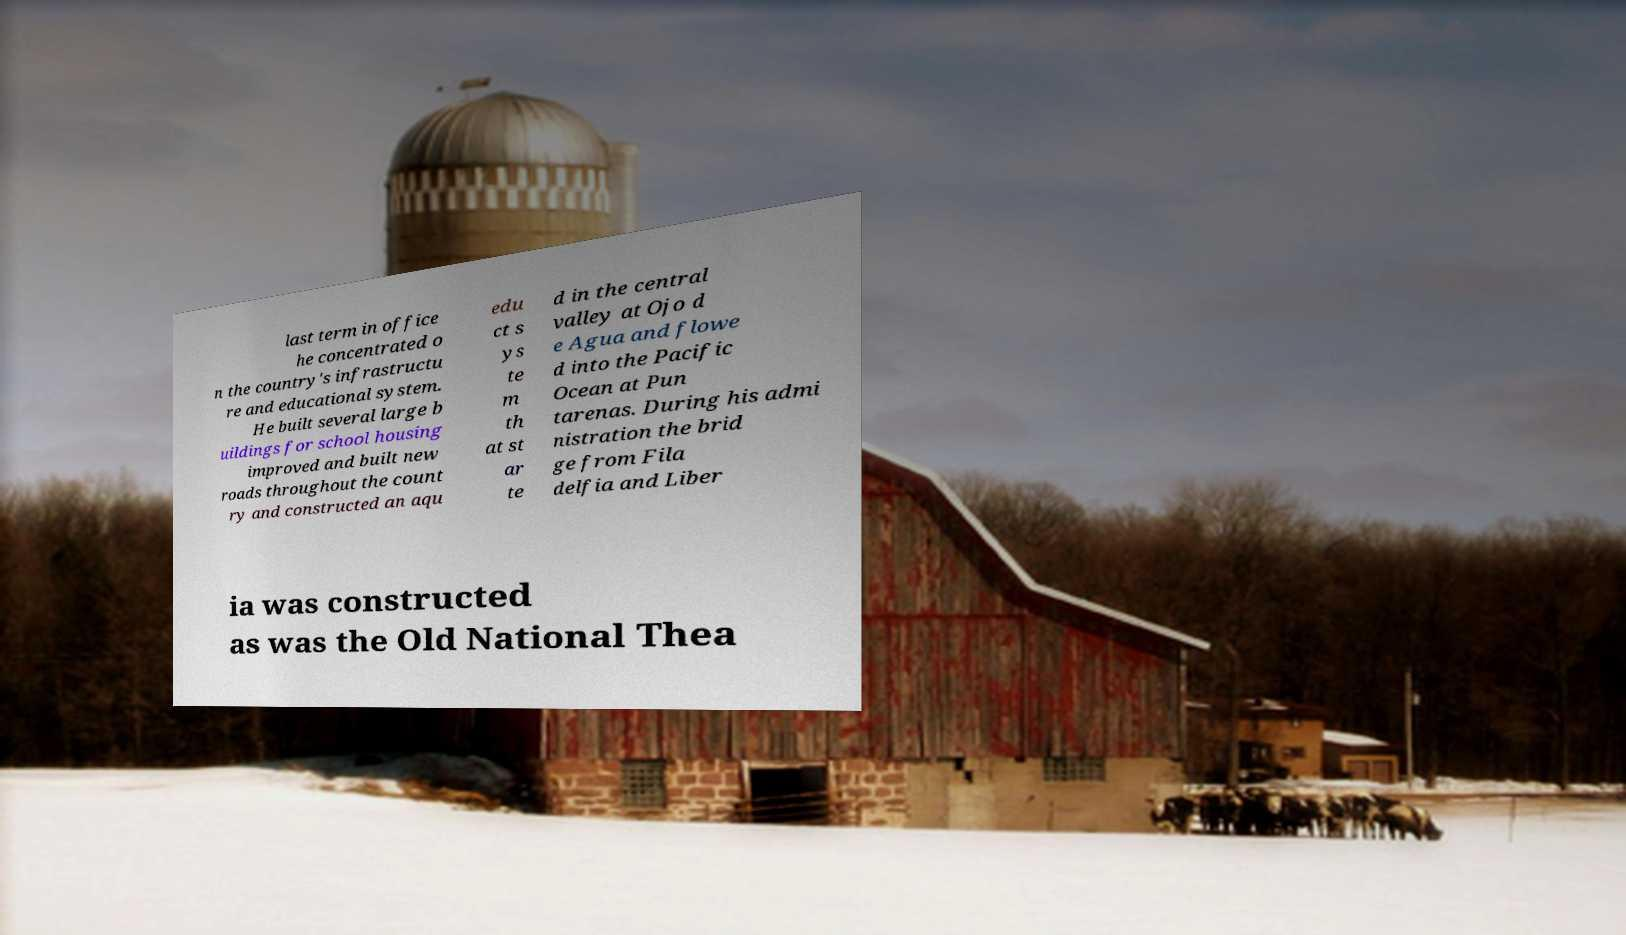Can you read and provide the text displayed in the image?This photo seems to have some interesting text. Can you extract and type it out for me? last term in office he concentrated o n the country's infrastructu re and educational system. He built several large b uildings for school housing improved and built new roads throughout the count ry and constructed an aqu edu ct s ys te m th at st ar te d in the central valley at Ojo d e Agua and flowe d into the Pacific Ocean at Pun tarenas. During his admi nistration the brid ge from Fila delfia and Liber ia was constructed as was the Old National Thea 